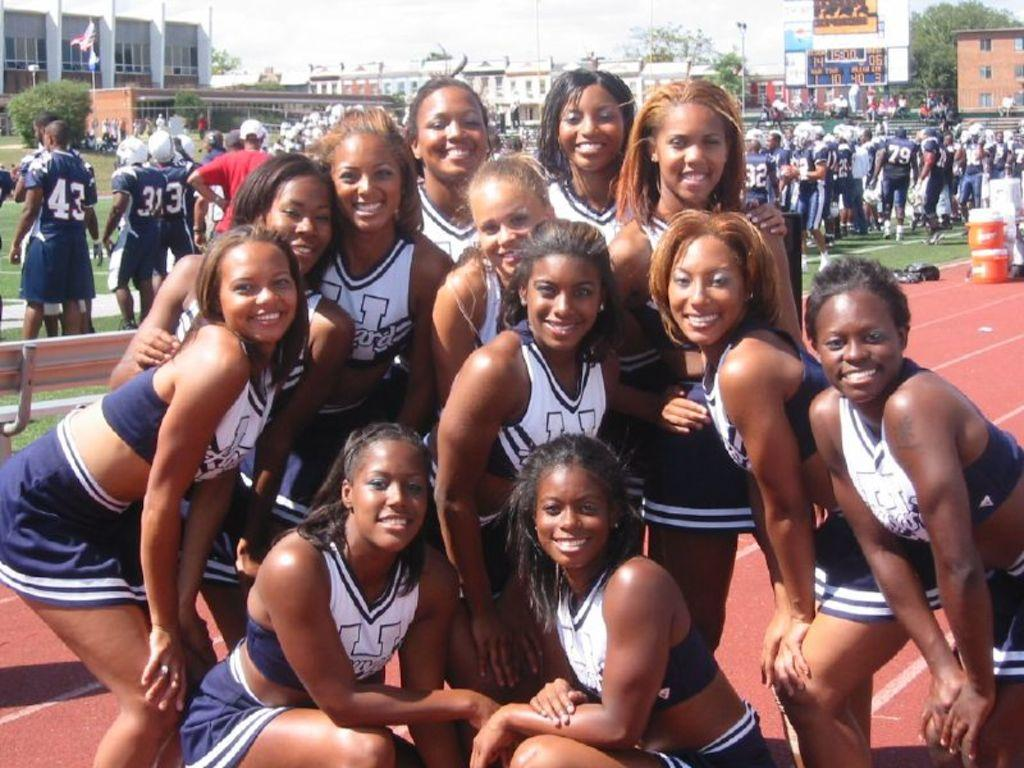Who is present in the image? There are women in the image. What can be seen in the background of the image? There are many people, trees, buildings, poles, flag poles, objects, a bench, and boxes in the background of the image. What part of the natural environment is visible in the image? The sky is visible in the background of the image. How does the beggar in the image support their family? There is no beggar present in the image; it features women and various elements in the background. 